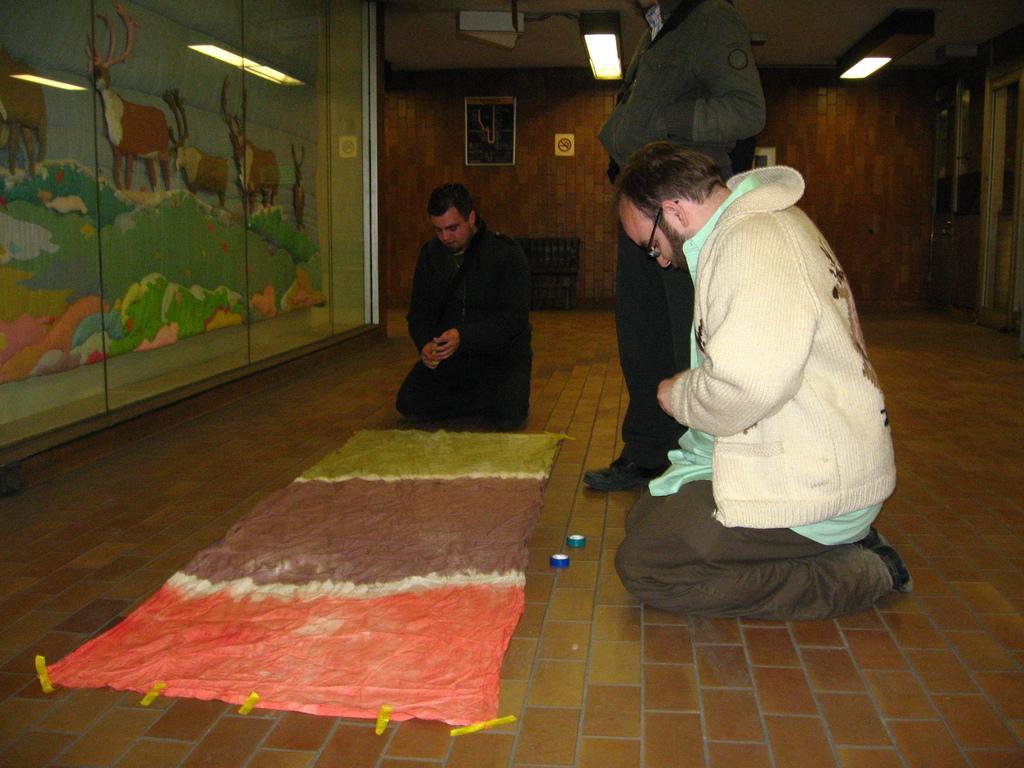Can you describe this image briefly? In this picture there are two persons on knees and there is a person standing. At the bottom there is a cloth and there are plasters. On the left side of the image there is a picture of deers on the grass. At the top there are lights. At the back there are frames on the wall. On the right side of the image there is a door. 